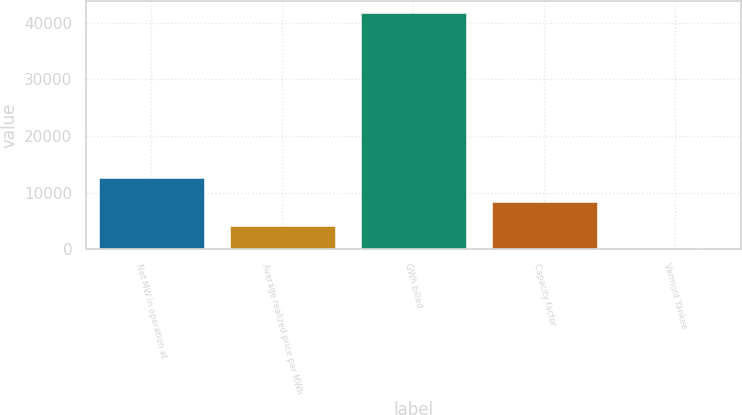<chart> <loc_0><loc_0><loc_500><loc_500><bar_chart><fcel>Net MW in operation at<fcel>Average realized price per MWh<fcel>GWh billed<fcel>Capacity factor<fcel>Vermont Yankee<nl><fcel>12528.4<fcel>4190.8<fcel>41710<fcel>8359.6<fcel>22<nl></chart> 